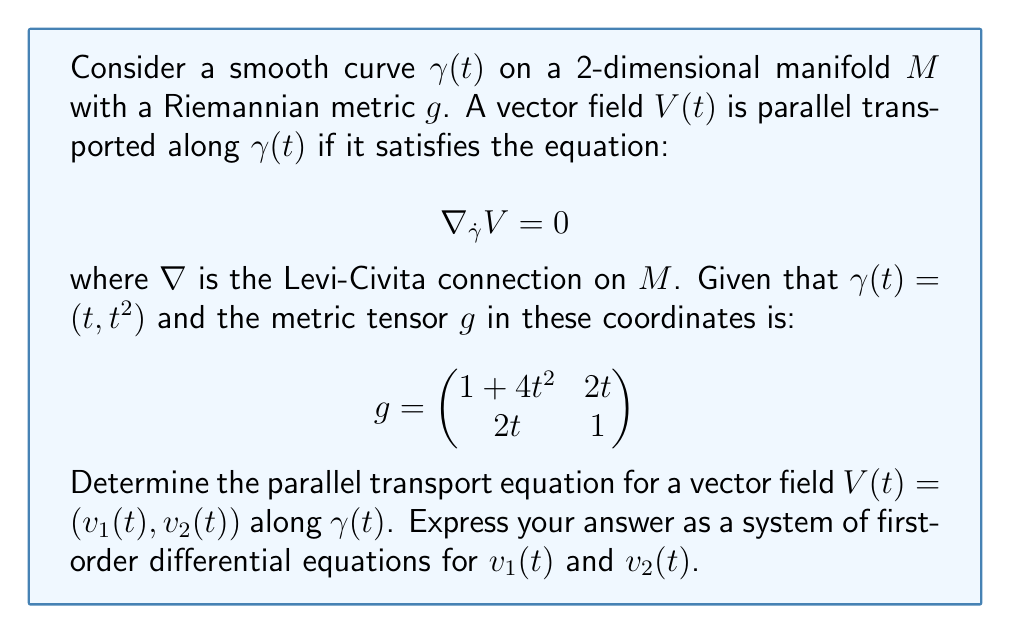Provide a solution to this math problem. Let's approach this step-by-step:

1) The parallel transport equation $\nabla_{\dot{\gamma}}V = 0$ in components is:

   $$\frac{dV^i}{dt} + \Gamma^i_{jk}\frac{d\gamma^j}{dt}V^k = 0$$

   where $\Gamma^i_{jk}$ are the Christoffel symbols.

2) We need to calculate $\dot{\gamma}$:
   
   $$\dot{\gamma} = (1, 2t)$$

3) To find the Christoffel symbols, we use the formula:

   $$\Gamma^i_{jk} = \frac{1}{2}g^{im}(\partial_j g_{mk} + \partial_k g_{mj} - \partial_m g_{jk})$$

4) First, we need the inverse metric $g^{-1}$:

   $$g^{-1} = \frac{1}{1+4t^2}\begin{pmatrix}
   1 & -2t \\
   -2t & 1+4t^2
   \end{pmatrix}$$

5) Calculating the non-zero Christoffel symbols:

   $$\Gamma^1_{11} = \frac{4t}{1+4t^2}, \Gamma^1_{12} = \Gamma^1_{21} = \frac{1}{1+4t^2}, \Gamma^2_{11} = -2t$$

6) Now, we can write the parallel transport equations:

   $$\frac{dv_1}{dt} + \Gamma^1_{11}\dot{\gamma}^1v_1 + \Gamma^1_{12}\dot{\gamma}^2v_1 + \Gamma^1_{21}\dot{\gamma}^1v_2 + \Gamma^1_{22}\dot{\gamma}^2v_2 = 0$$
   $$\frac{dv_2}{dt} + \Gamma^2_{11}\dot{\gamma}^1v_1 + \Gamma^2_{12}\dot{\gamma}^2v_1 + \Gamma^2_{21}\dot{\gamma}^1v_2 + \Gamma^2_{22}\dot{\gamma}^2v_2 = 0$$

7) Substituting the values:

   $$\frac{dv_1}{dt} + \frac{4t}{1+4t^2}v_1 + \frac{1}{1+4t^2}(2t)v_1 + \frac{1}{1+4t^2}v_2 + 0 = 0$$
   $$\frac{dv_2}{dt} + (-2t)v_1 + 0 + 0 + 0 = 0$$

8) Simplifying:

   $$\frac{dv_1}{dt} + \frac{4t+4t^2}{1+4t^2}v_1 + \frac{1}{1+4t^2}v_2 = 0$$
   $$\frac{dv_2}{dt} - 2tv_1 = 0$$
Answer: $$\begin{cases}
\frac{dv_1}{dt} = -\frac{4t+4t^2}{1+4t^2}v_1 - \frac{1}{1+4t^2}v_2 \\
\frac{dv_2}{dt} = 2tv_1
\end{cases}$$ 